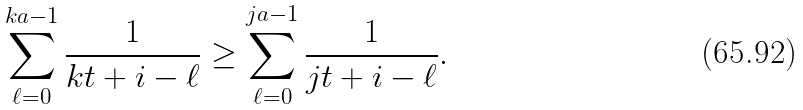<formula> <loc_0><loc_0><loc_500><loc_500>\sum _ { \ell = 0 } ^ { k a - 1 } \frac { 1 } { k t + i - \ell } \geq \sum _ { \ell = 0 } ^ { j a - 1 } \frac { 1 } { j t + i - \ell } .</formula> 